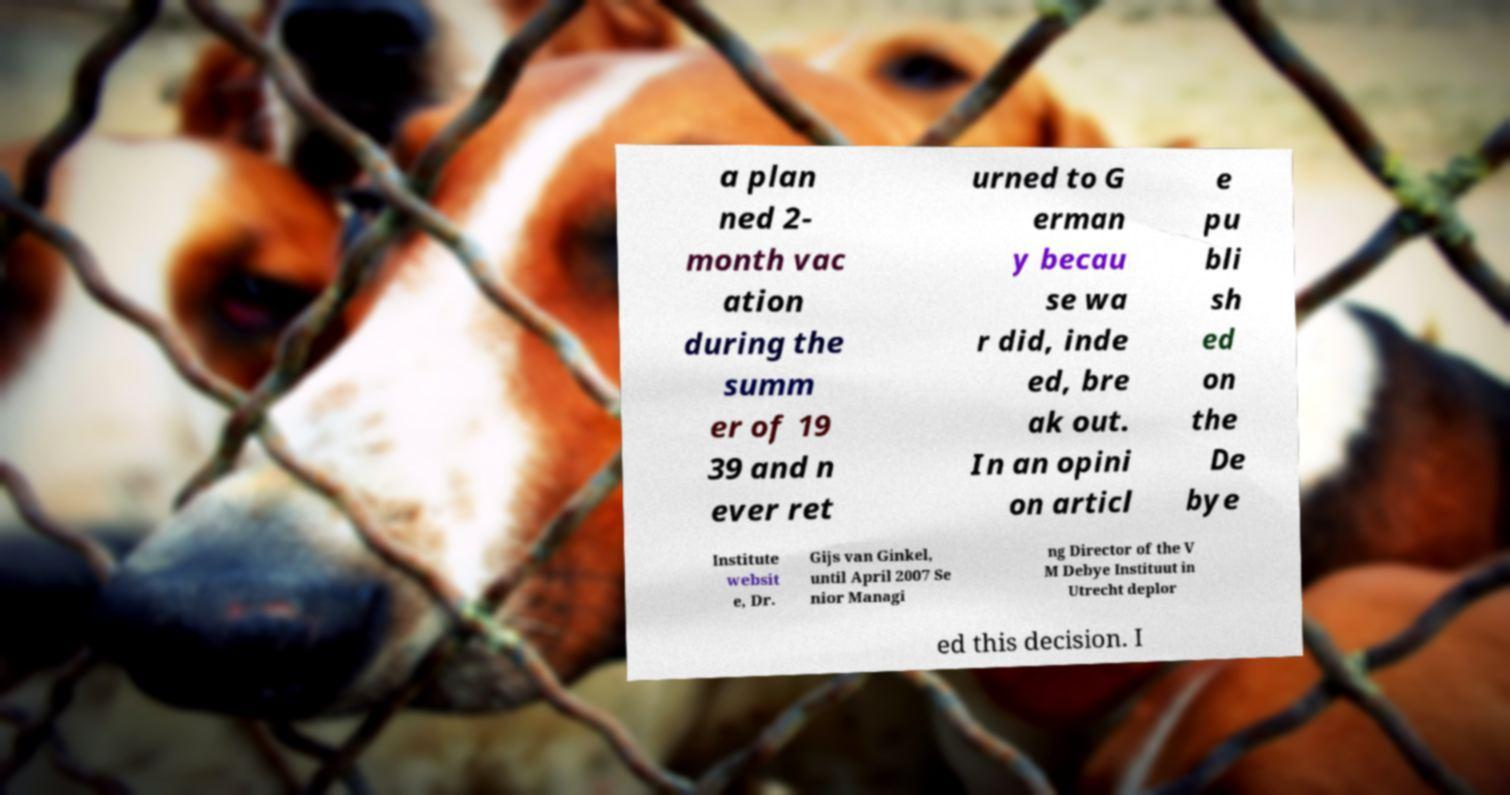Can you accurately transcribe the text from the provided image for me? a plan ned 2- month vac ation during the summ er of 19 39 and n ever ret urned to G erman y becau se wa r did, inde ed, bre ak out. In an opini on articl e pu bli sh ed on the De bye Institute websit e, Dr. Gijs van Ginkel, until April 2007 Se nior Managi ng Director of the V M Debye Instituut in Utrecht deplor ed this decision. I 